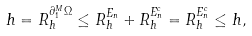Convert formula to latex. <formula><loc_0><loc_0><loc_500><loc_500>h = R ^ { \partial _ { 1 } ^ { M } \Omega } _ { h } \leq R _ { h } ^ { E _ { n } } + R _ { h } ^ { E _ { n } ^ { c } } = R _ { h } ^ { E _ { n } ^ { c } } \leq h ,</formula> 